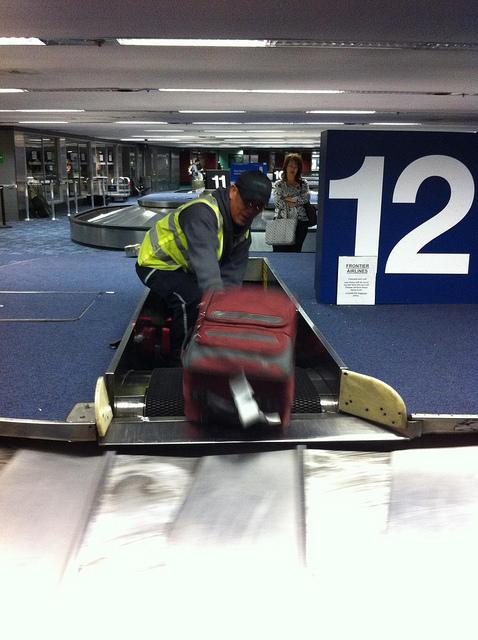Who employs the man in the yellow vest? airport 